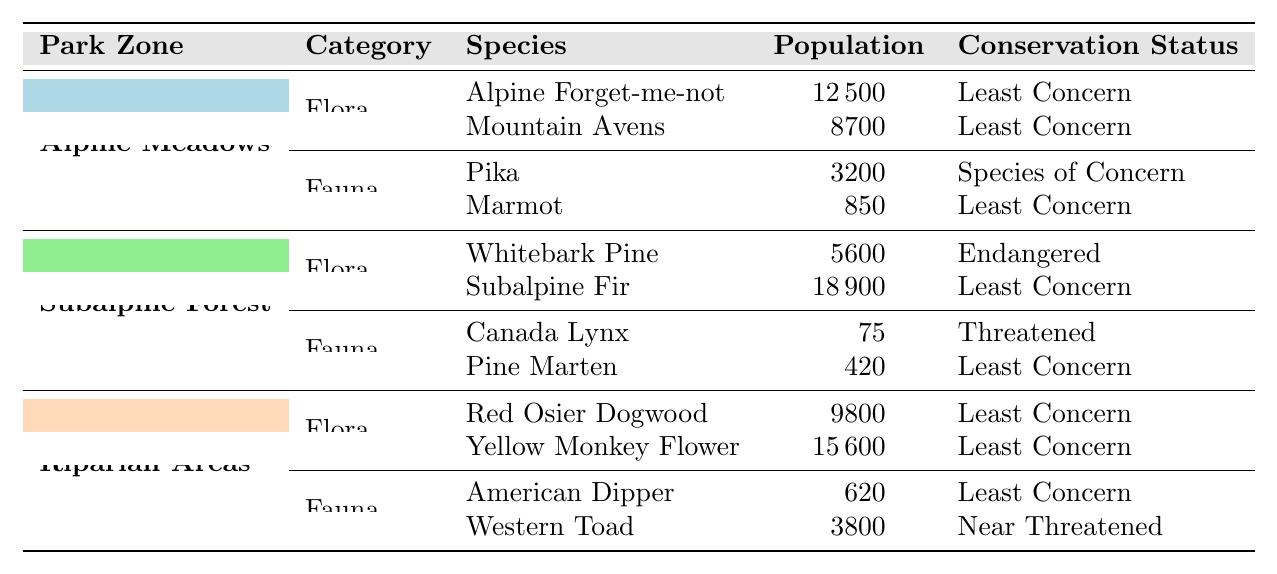What is the population of the Canada Lynx in the Subalpine Forest zone? The table shows that the population of the Canada Lynx is listed under the Subalpine Forest zone with a specific population value. I can find that population in the corresponding row for the Canada Lynx.
Answer: 75 How many native flora species are present in the Riparian Areas zone? In the Riparian Areas zone, there are two species listed under the Flora category. By looking at the Flora rows, I note down the number of species.
Answer: 2 What is the conservation status of the Whitebark Pine? The conservation status of the Whitebark Pine is specified in the table in the row corresponding to its species under the Flora category in the Subalpine Forest zone. I can simply read that directly from the table.
Answer: Endangered Which zone has the highest total population of native fauna species? I will sum the population of fauna species in each zone: Alpine Meadows has 3200 + 850 = 4050, Subalpine Forest has 75 + 420 = 495, and Riparian Areas has 620 + 3800 = 4420. Comparing these totals, I find that the Alpine Meadows has the highest population of fauna species.
Answer: Alpine Meadows Is the overall conservation status for native species in the Alpine Meadows primarily "Least Concern"? In the Alpine Meadows, I check the conservation statuses of all native species and note that out of four entries, three have the status "Least Concern." Therefore, the overall status can be categorized accordingly.
Answer: Yes What is the difference in population between the Mountain Avens and the Yellow Monkey Flower? I look at the table to find the population of Mountain Avens (8700) and Yellow Monkey Flower (15600) under the respective flora categories. The difference is calculated as 15600 - 8700.
Answer: 6900 Which fauna species in the Riparian Areas has a population classified as "Least Concern"? In the Riparian Areas zone, I examine the fauna section and list the species and their conservation statuses. I note that the American Dipper and the Western Toad both have the status "Least Concern."
Answer: American Dipper and Western Toad What is the total population of native flora across all park zones? I will add the populations of the flora species listed in each zone: Alpine Meadows has 12500 + 8700 = 21200, Subalpine Forest has 5600 + 18900 = 24500, and Riparian Areas has 9800 + 15600 = 25400. Summing these totals gives me 21200 + 24500 + 25400.
Answer: 71100 